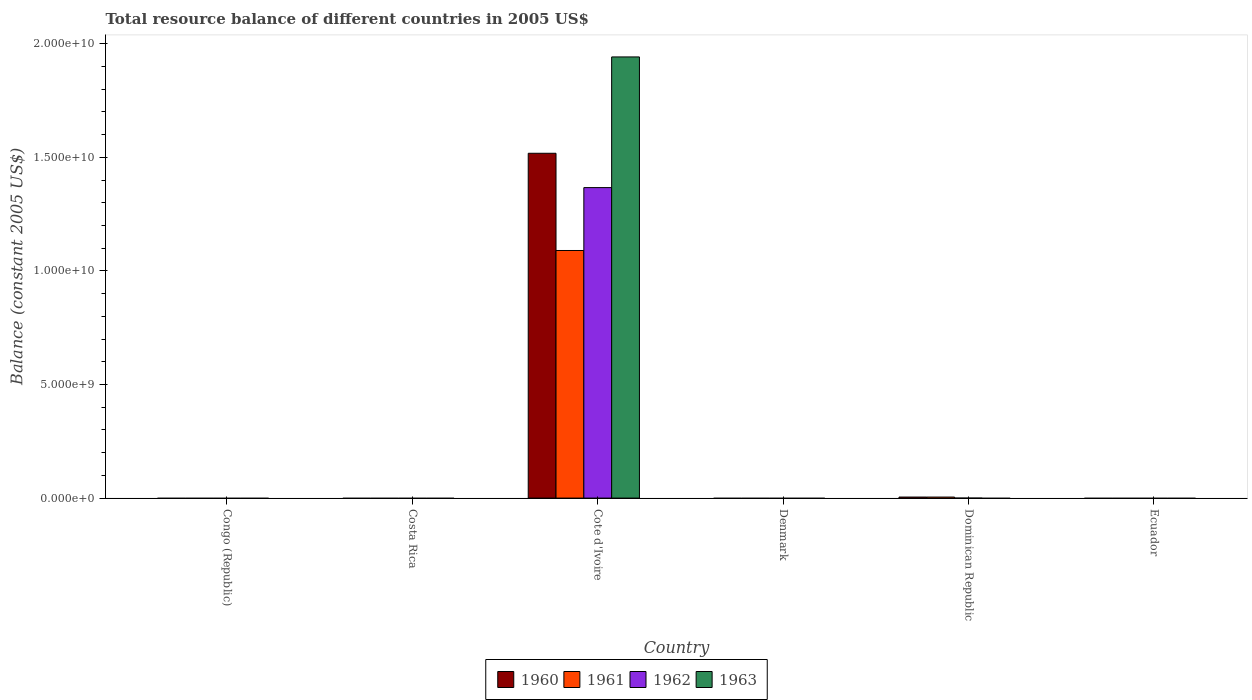How many bars are there on the 3rd tick from the right?
Make the answer very short. 0. What is the total resource balance in 1961 in Dominican Republic?
Provide a succinct answer. 4.52e+07. Across all countries, what is the maximum total resource balance in 1962?
Make the answer very short. 1.37e+1. Across all countries, what is the minimum total resource balance in 1962?
Provide a short and direct response. 0. In which country was the total resource balance in 1960 maximum?
Make the answer very short. Cote d'Ivoire. What is the total total resource balance in 1961 in the graph?
Provide a succinct answer. 1.09e+1. What is the difference between the total resource balance in 1960 in Cote d'Ivoire and the total resource balance in 1963 in Ecuador?
Provide a short and direct response. 1.52e+1. What is the average total resource balance in 1960 per country?
Your response must be concise. 2.54e+09. What is the difference between the total resource balance of/in 1961 and total resource balance of/in 1960 in Cote d'Ivoire?
Ensure brevity in your answer.  -4.28e+09. What is the difference between the highest and the lowest total resource balance in 1961?
Your response must be concise. 1.09e+1. Is it the case that in every country, the sum of the total resource balance in 1962 and total resource balance in 1963 is greater than the total resource balance in 1961?
Provide a succinct answer. No. Does the graph contain any zero values?
Provide a succinct answer. Yes. Where does the legend appear in the graph?
Your response must be concise. Bottom center. How many legend labels are there?
Offer a very short reply. 4. What is the title of the graph?
Ensure brevity in your answer.  Total resource balance of different countries in 2005 US$. What is the label or title of the X-axis?
Offer a terse response. Country. What is the label or title of the Y-axis?
Your answer should be very brief. Balance (constant 2005 US$). What is the Balance (constant 2005 US$) of 1960 in Congo (Republic)?
Provide a short and direct response. 0. What is the Balance (constant 2005 US$) in 1961 in Congo (Republic)?
Your answer should be very brief. 0. What is the Balance (constant 2005 US$) of 1962 in Congo (Republic)?
Your answer should be very brief. 0. What is the Balance (constant 2005 US$) of 1960 in Costa Rica?
Your answer should be very brief. 0. What is the Balance (constant 2005 US$) of 1961 in Costa Rica?
Provide a succinct answer. 0. What is the Balance (constant 2005 US$) in 1962 in Costa Rica?
Provide a short and direct response. 0. What is the Balance (constant 2005 US$) of 1960 in Cote d'Ivoire?
Your answer should be very brief. 1.52e+1. What is the Balance (constant 2005 US$) in 1961 in Cote d'Ivoire?
Make the answer very short. 1.09e+1. What is the Balance (constant 2005 US$) of 1962 in Cote d'Ivoire?
Provide a short and direct response. 1.37e+1. What is the Balance (constant 2005 US$) of 1963 in Cote d'Ivoire?
Give a very brief answer. 1.94e+1. What is the Balance (constant 2005 US$) of 1962 in Denmark?
Your response must be concise. 0. What is the Balance (constant 2005 US$) in 1963 in Denmark?
Make the answer very short. 0. What is the Balance (constant 2005 US$) of 1960 in Dominican Republic?
Offer a terse response. 4.56e+07. What is the Balance (constant 2005 US$) in 1961 in Dominican Republic?
Provide a succinct answer. 4.52e+07. What is the Balance (constant 2005 US$) of 1962 in Dominican Republic?
Provide a succinct answer. 0. What is the Balance (constant 2005 US$) of 1960 in Ecuador?
Offer a very short reply. 0. What is the Balance (constant 2005 US$) in 1961 in Ecuador?
Keep it short and to the point. 0. What is the Balance (constant 2005 US$) of 1962 in Ecuador?
Your response must be concise. 0. What is the Balance (constant 2005 US$) in 1963 in Ecuador?
Provide a succinct answer. 0. Across all countries, what is the maximum Balance (constant 2005 US$) of 1960?
Offer a terse response. 1.52e+1. Across all countries, what is the maximum Balance (constant 2005 US$) of 1961?
Your answer should be very brief. 1.09e+1. Across all countries, what is the maximum Balance (constant 2005 US$) in 1962?
Ensure brevity in your answer.  1.37e+1. Across all countries, what is the maximum Balance (constant 2005 US$) in 1963?
Provide a short and direct response. 1.94e+1. Across all countries, what is the minimum Balance (constant 2005 US$) of 1960?
Ensure brevity in your answer.  0. Across all countries, what is the minimum Balance (constant 2005 US$) of 1962?
Give a very brief answer. 0. What is the total Balance (constant 2005 US$) of 1960 in the graph?
Offer a very short reply. 1.52e+1. What is the total Balance (constant 2005 US$) of 1961 in the graph?
Keep it short and to the point. 1.09e+1. What is the total Balance (constant 2005 US$) of 1962 in the graph?
Your response must be concise. 1.37e+1. What is the total Balance (constant 2005 US$) of 1963 in the graph?
Your response must be concise. 1.94e+1. What is the difference between the Balance (constant 2005 US$) in 1960 in Cote d'Ivoire and that in Dominican Republic?
Provide a succinct answer. 1.51e+1. What is the difference between the Balance (constant 2005 US$) of 1961 in Cote d'Ivoire and that in Dominican Republic?
Make the answer very short. 1.09e+1. What is the difference between the Balance (constant 2005 US$) in 1960 in Cote d'Ivoire and the Balance (constant 2005 US$) in 1961 in Dominican Republic?
Provide a succinct answer. 1.51e+1. What is the average Balance (constant 2005 US$) in 1960 per country?
Provide a succinct answer. 2.54e+09. What is the average Balance (constant 2005 US$) in 1961 per country?
Your answer should be very brief. 1.82e+09. What is the average Balance (constant 2005 US$) of 1962 per country?
Ensure brevity in your answer.  2.28e+09. What is the average Balance (constant 2005 US$) of 1963 per country?
Provide a short and direct response. 3.24e+09. What is the difference between the Balance (constant 2005 US$) in 1960 and Balance (constant 2005 US$) in 1961 in Cote d'Ivoire?
Your answer should be very brief. 4.28e+09. What is the difference between the Balance (constant 2005 US$) in 1960 and Balance (constant 2005 US$) in 1962 in Cote d'Ivoire?
Give a very brief answer. 1.51e+09. What is the difference between the Balance (constant 2005 US$) of 1960 and Balance (constant 2005 US$) of 1963 in Cote d'Ivoire?
Offer a very short reply. -4.24e+09. What is the difference between the Balance (constant 2005 US$) in 1961 and Balance (constant 2005 US$) in 1962 in Cote d'Ivoire?
Make the answer very short. -2.77e+09. What is the difference between the Balance (constant 2005 US$) of 1961 and Balance (constant 2005 US$) of 1963 in Cote d'Ivoire?
Your answer should be compact. -8.52e+09. What is the difference between the Balance (constant 2005 US$) in 1962 and Balance (constant 2005 US$) in 1963 in Cote d'Ivoire?
Provide a short and direct response. -5.75e+09. What is the difference between the Balance (constant 2005 US$) of 1960 and Balance (constant 2005 US$) of 1961 in Dominican Republic?
Provide a short and direct response. 4.00e+05. What is the ratio of the Balance (constant 2005 US$) of 1960 in Cote d'Ivoire to that in Dominican Republic?
Make the answer very short. 332.91. What is the ratio of the Balance (constant 2005 US$) of 1961 in Cote d'Ivoire to that in Dominican Republic?
Keep it short and to the point. 241.17. What is the difference between the highest and the lowest Balance (constant 2005 US$) in 1960?
Ensure brevity in your answer.  1.52e+1. What is the difference between the highest and the lowest Balance (constant 2005 US$) of 1961?
Keep it short and to the point. 1.09e+1. What is the difference between the highest and the lowest Balance (constant 2005 US$) of 1962?
Your response must be concise. 1.37e+1. What is the difference between the highest and the lowest Balance (constant 2005 US$) of 1963?
Your answer should be very brief. 1.94e+1. 